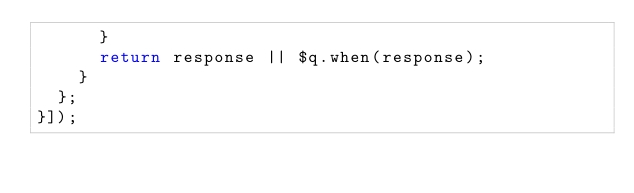<code> <loc_0><loc_0><loc_500><loc_500><_JavaScript_>      }
      return response || $q.when(response);
    }
  };
}]);
</code> 